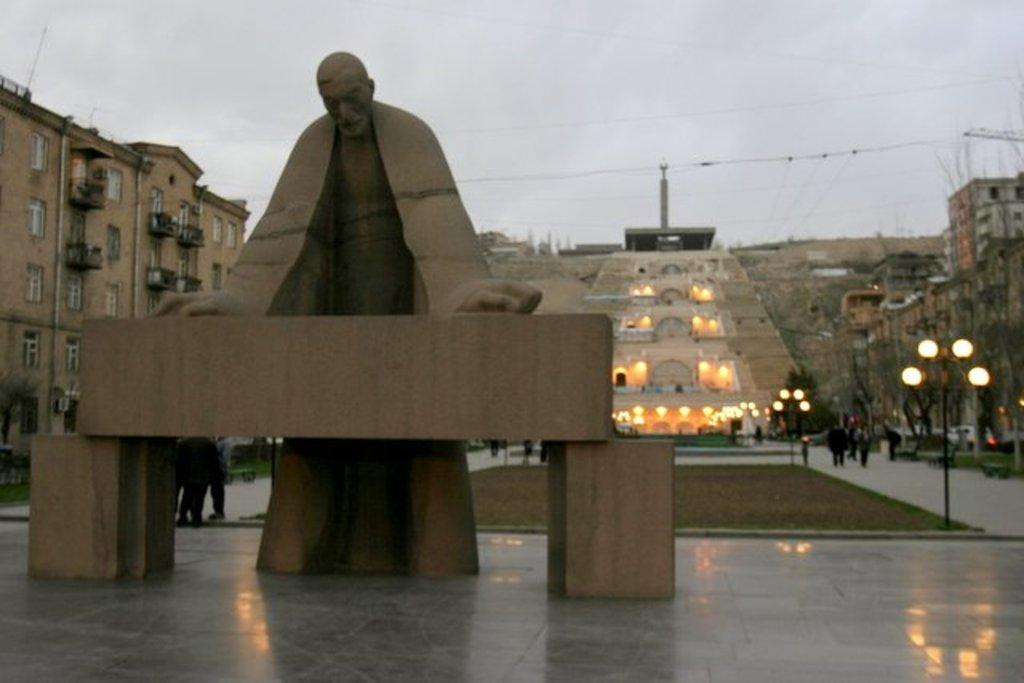What is the main subject in the image? There is a sculpture in the image. What can be seen on either side of the sculpture? There are buildings and light poles on either side of the sculpture. What is visible in the background of the image? There is architecture and the sky visible in the background. What type of pear is hanging from the light pole in the image? There is no pear present in the image; it features a sculpture with buildings and light poles on either side. 